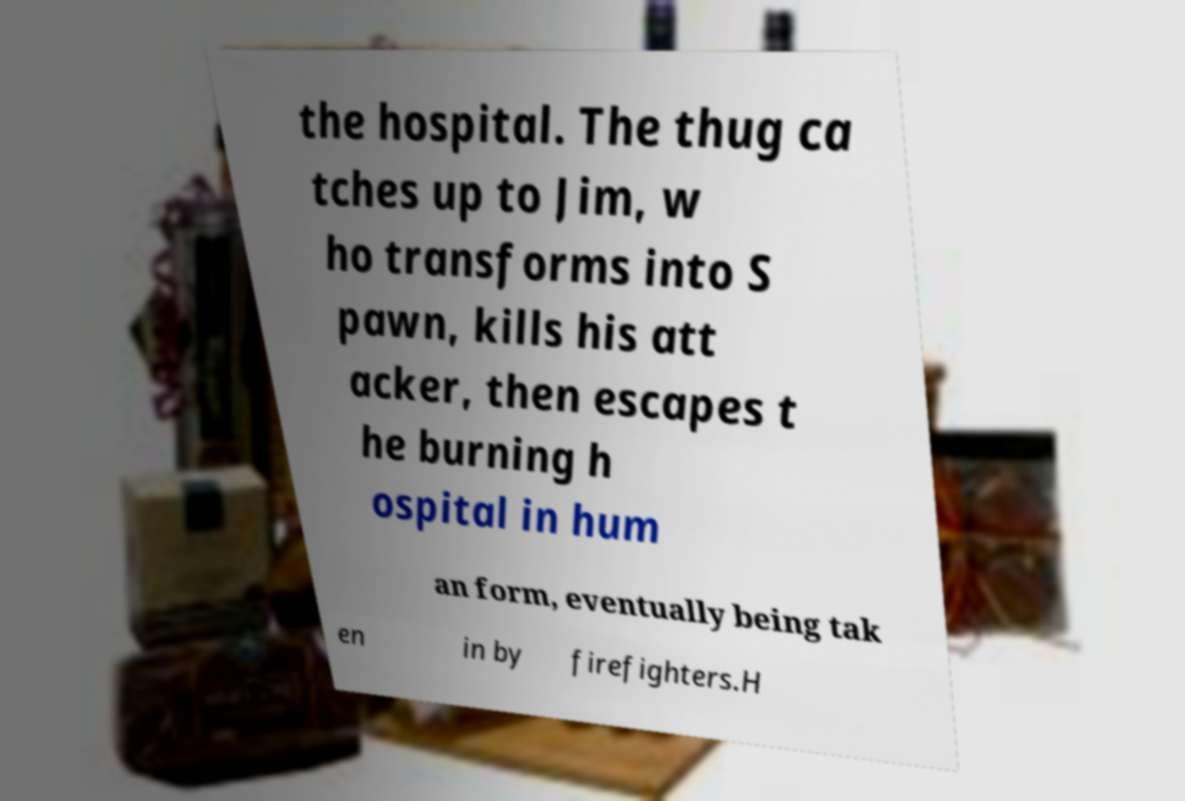Could you assist in decoding the text presented in this image and type it out clearly? the hospital. The thug ca tches up to Jim, w ho transforms into S pawn, kills his att acker, then escapes t he burning h ospital in hum an form, eventually being tak en in by firefighters.H 